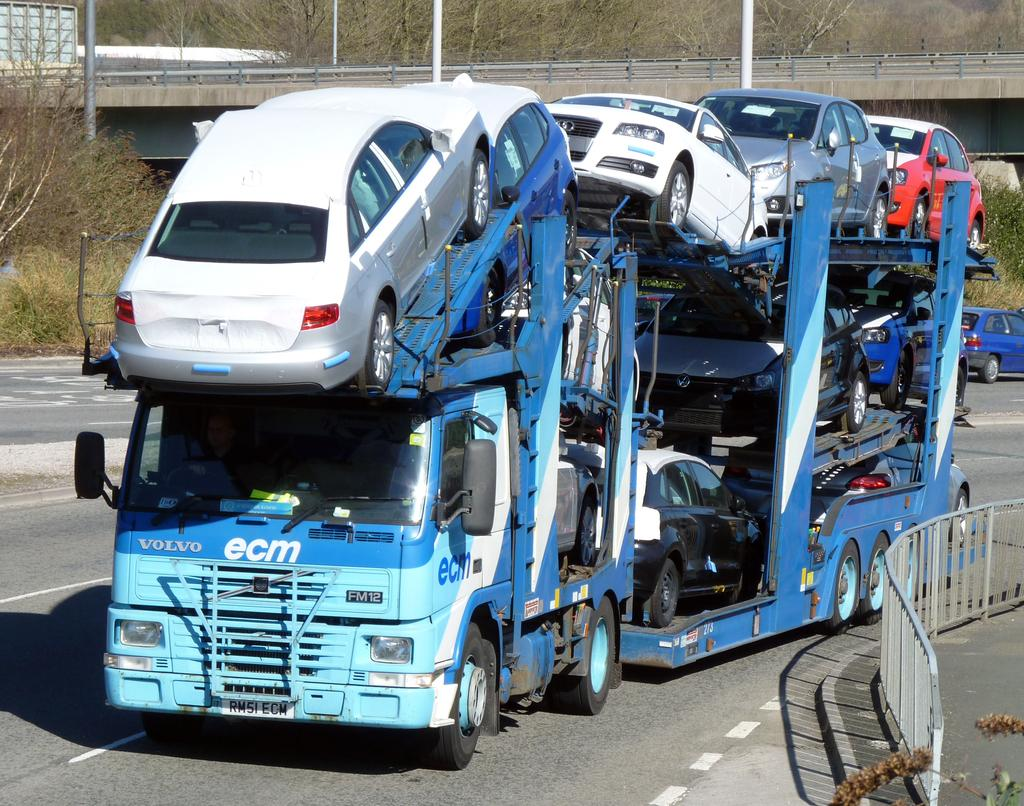What can be seen on the road in the image? There are many vehicles on the road in the image. Can you describe one of the vehicles in the image? One of the vehicles is blue. What can be seen in the background of the image? There are dried trees and a bridge in the background of the image. What type of ball is the squirrel holding with its finger in the image? There is no squirrel, ball, or finger present in the image. 